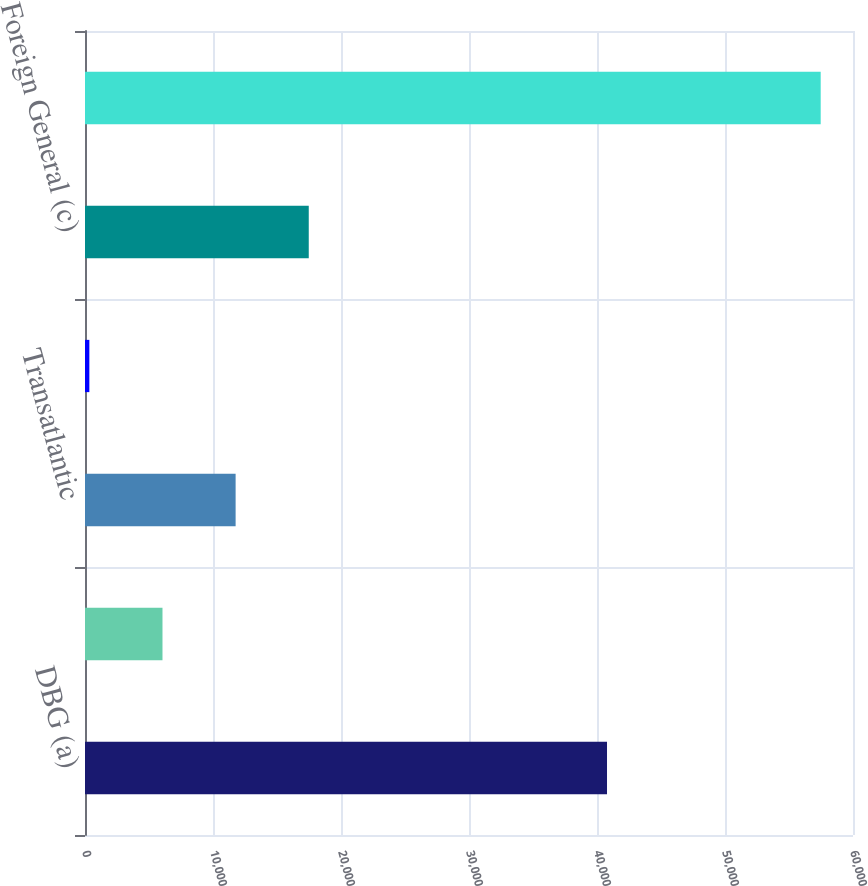Convert chart to OTSL. <chart><loc_0><loc_0><loc_500><loc_500><bar_chart><fcel>DBG (a)<fcel>Personal Lines (b)<fcel>Transatlantic<fcel>Mortgage Guaranty<fcel>Foreign General (c)<fcel>Total Net Loss Reserve<nl><fcel>40782<fcel>6053.6<fcel>11767.2<fcel>340<fcel>17480.8<fcel>57476<nl></chart> 